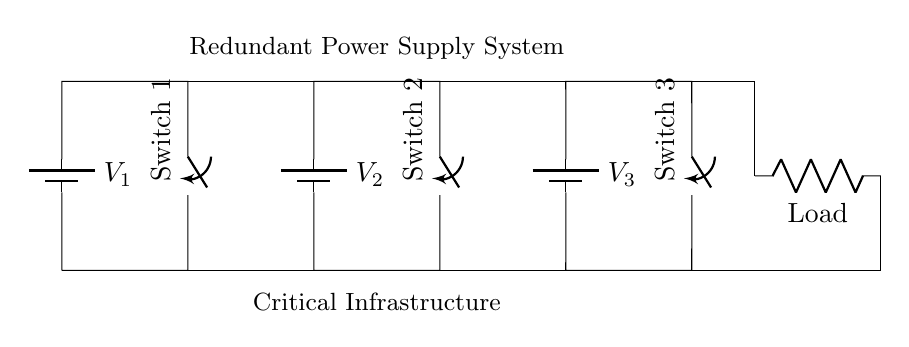What is the total number of batteries in the circuit? The circuit has three batteries, labeled V1, V2, and V3, that are drawn in series along the top.
Answer: 3 What are the components used in this circuit? The circuit consists of three batteries, three switches, and one load resistor. The switches are used to control the flow of electricity from the batteries to the load.
Answer: batteries, switches, load What does the load represent in this circuit? The load in this circuit represents the device or system being powered, which requires electrical energy from the redundant power supply.
Answer: Load If one battery fails, how many operational batteries remain? Since this is a series circuit, if one battery (for example, V1) fails, the current path is broken, and the other batteries cannot supply power to the load. Thus, there are effectively zero operational batteries.
Answer: 0 What is the purpose of having multiple switches in this circuit? The purpose of having multiple switches is to provide redundancy; each switch can isolate a battery from the load, allowing for maintenance or failure management without losing power supply.
Answer: Redundancy What voltage does each battery supply? The diagram does not specify the exact voltage values for each battery; they are indicated simply as V1, V2, and V3 without numerical values.
Answer: Not specified How does the failure of one battery affect the total voltage supplied to the load? In a series circuit, the failure of one battery will result in the complete loss of voltage to the load, as the series connection requires all batteries to be functioning for the current to flow.
Answer: Zero volts 